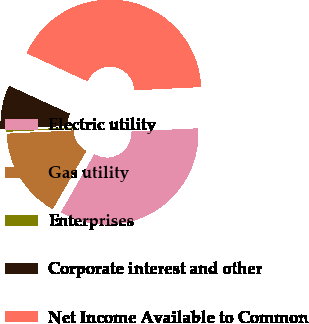<chart> <loc_0><loc_0><loc_500><loc_500><pie_chart><fcel>Electric utility<fcel>Gas utility<fcel>Enterprises<fcel>Corporate interest and other<fcel>Net Income Available to Common<nl><fcel>34.1%<fcel>15.9%<fcel>0.09%<fcel>7.55%<fcel>42.36%<nl></chart> 